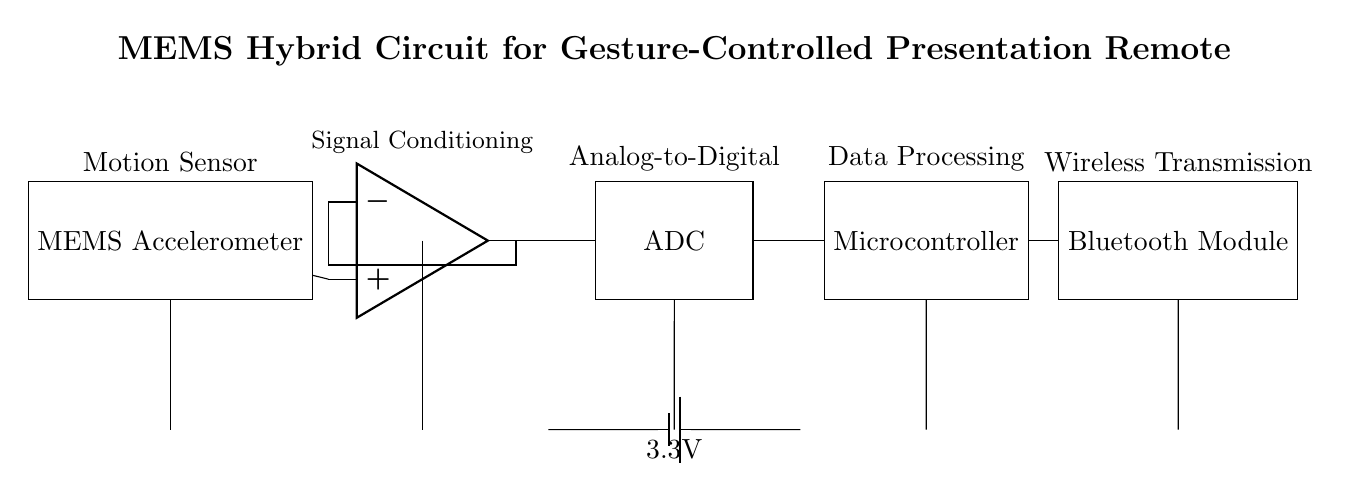What component is used for motion sensing? The motion sensing component in the circuit is the MEMS Accelerometer, which is specifically designed to detect changes in motion or position.
Answer: MEMS Accelerometer What is the main function of the amplifier? The amplifier's role here is signal conditioning, which means it processes and amplifies the analog signals received from the MEMS Accelerometer for further processing.
Answer: Signal Conditioning What voltage is supplied to the circuit? The circuit is powered by a 3.3V battery, as indicated by the label near the power connections in the diagram.
Answer: 3.3V Which component is responsible for data transmission? The component that handles wireless transmission of data in the circuit is the Bluetooth Module. It connects to the microcontroller to send processed data wirelessly.
Answer: Bluetooth Module How are the components powered? All components receive power from a common power supply (the battery), as shown by the connections from the battery to each component in the circuit.
Answer: Through battery connections What type of conversion is performed by the ADC? The ADC performs analog-to-digital conversion, which means it converts the analog signals from the amplifier into digital signals for processing by the microcontroller.
Answer: Analog-to-Digital Why is a microcontroller used in this circuit? The microcontroller is necessary for data processing; it interprets the digital signals from the ADC and makes decisions based on the motion data received, which is essential for the gesture-controlled functionality.
Answer: Data Processing 